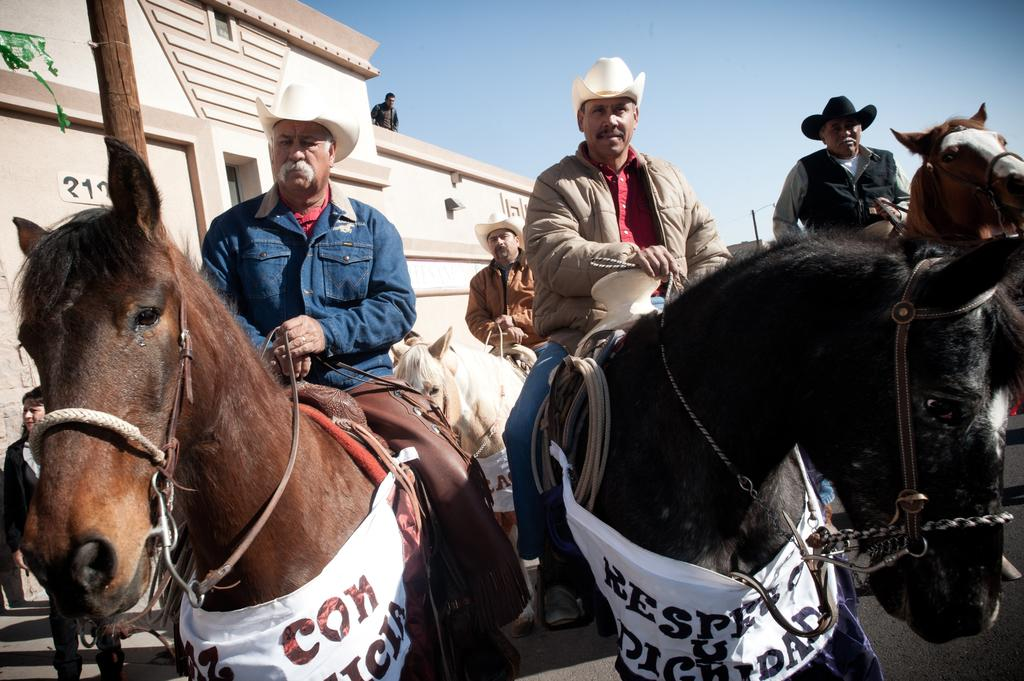What is happening in the image? There is a group of people in the image, and some of them are riding horses. Can you describe the setting of the image? There is a house in the background of the image. What type of class is being taught in the image? There is no class or teaching activity depicted in the image; it features a group of people riding horses. How many crows are visible in the image? There are no crows present in the image. 